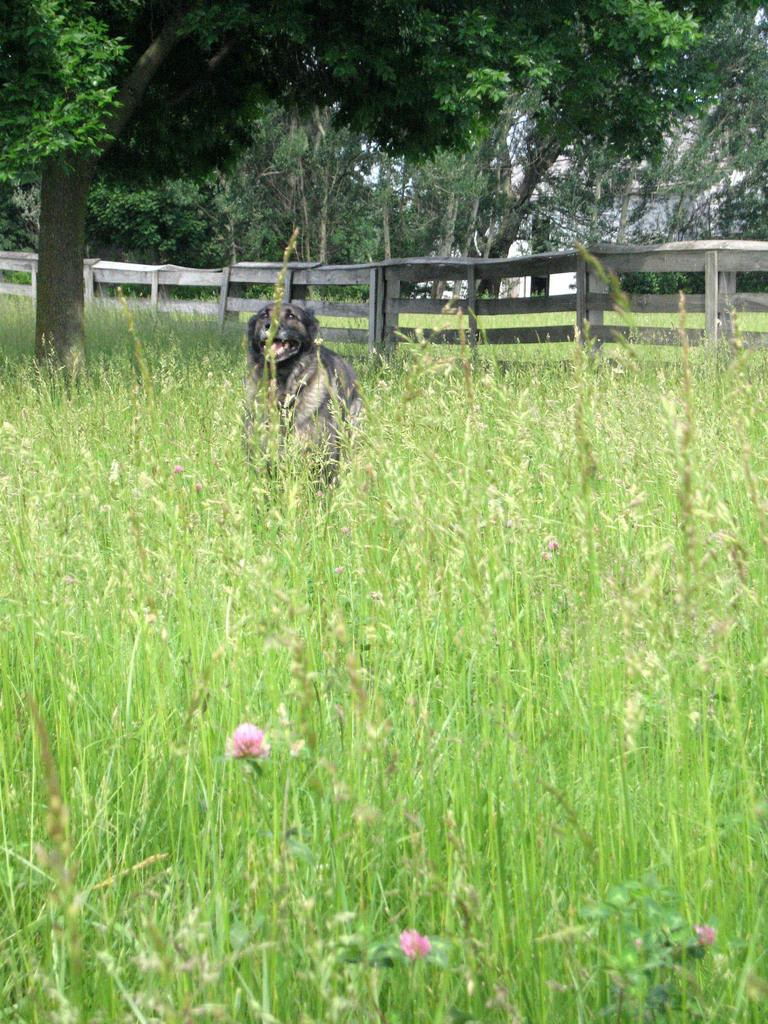What type of living organisms can be seen on the ground in the image? There are plants on the ground in the image. What animal is present in the image? There is a dog in the image. What type of barrier can be seen in the image? There is a wooden fence in the image. What can be seen in the background of the image? There are trees in the background of the image. Can you tell me how many people are in the group in the image? There is no group of people present in the image; it features plants, a dog, a wooden fence, and trees in the background. Is the shop open or closed in the image? There is no shop present in the image. 